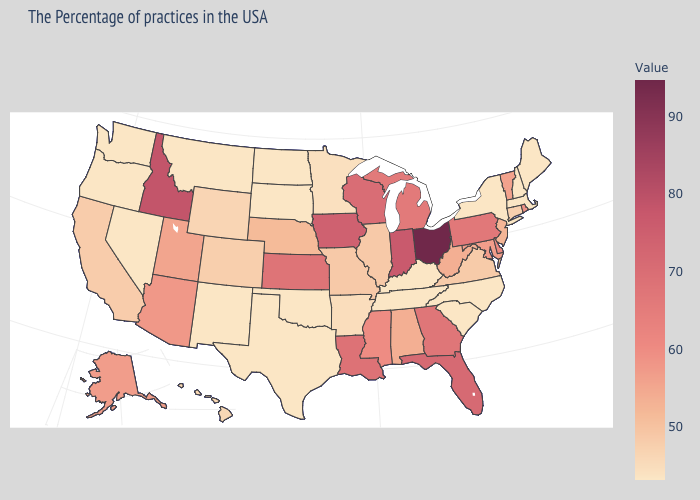Among the states that border New Jersey , does New York have the lowest value?
Concise answer only. Yes. Does Missouri have a higher value than Rhode Island?
Write a very short answer. No. Which states have the highest value in the USA?
Be succinct. Ohio. Among the states that border Connecticut , which have the highest value?
Give a very brief answer. Rhode Island. Does the map have missing data?
Be succinct. No. Does Iowa have a higher value than Delaware?
Quick response, please. Yes. 